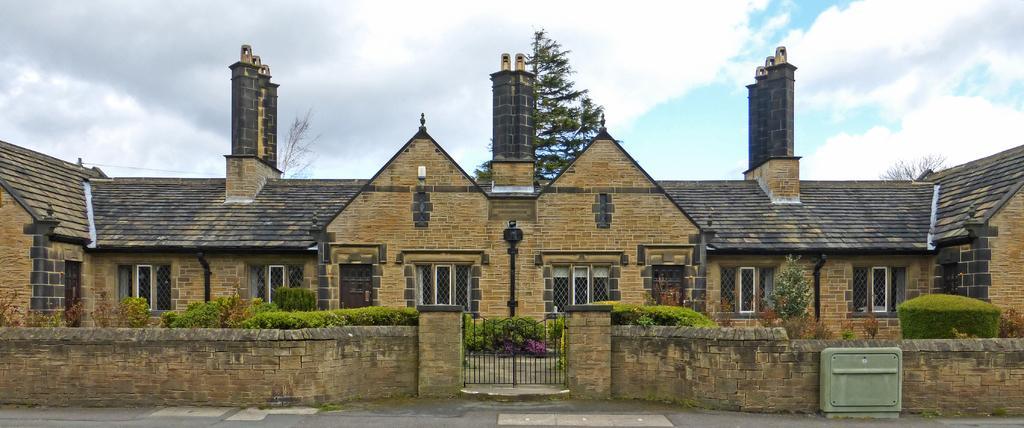Can you describe this image briefly? In this picture, we see a house with a black color roof. In the middle of the picture, we see a gate. Beside the gate, we see a wall. Beside the wall, there are plants and shrubs. In the right bottom of the picture, there is something which looks like a box. There are trees in the background. At the top of the picture, we see the sky and the clouds. 